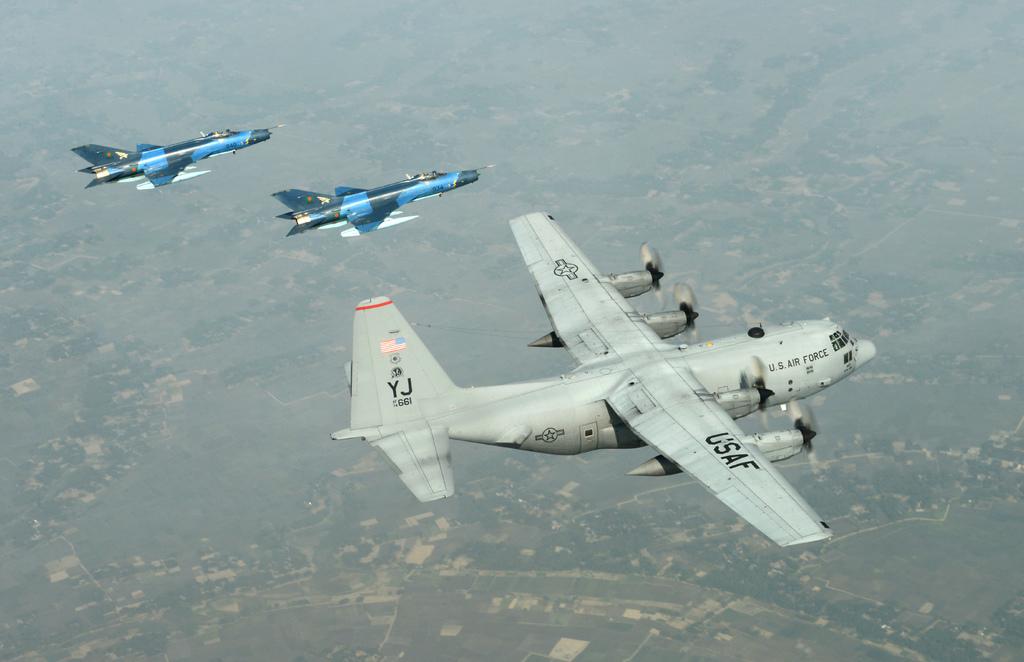What country does this plane belong to?
Offer a terse response. Usa. What branch of the military is this plane?
Keep it short and to the point. Usaf. 